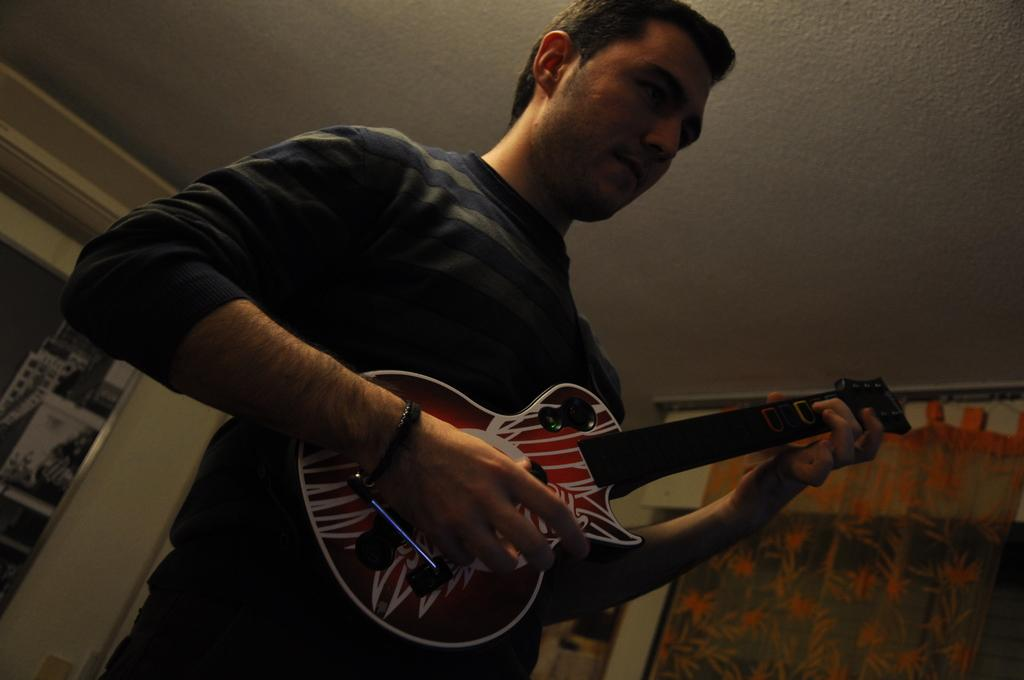What is the main subject of the image? There is a man in the image. What is the man doing in the image? The man is standing and playing the guitar. What is the man holding in the image? The man is holding a guitar. What can be seen near a window in the image? There is a curtain near a window in the image. What is the weight of the guitar in the image? The weight of the guitar cannot be determined from the image alone. What journey is the man taking in the image? There is no indication of a journey in the image. 